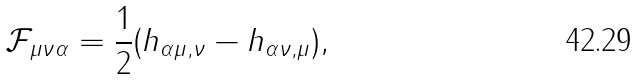Convert formula to latex. <formula><loc_0><loc_0><loc_500><loc_500>\mathcal { F } _ { \mu \nu \alpha } = \frac { 1 } { 2 } ( h _ { \alpha \mu , \nu } - h _ { \alpha \nu , \mu } ) ,</formula> 